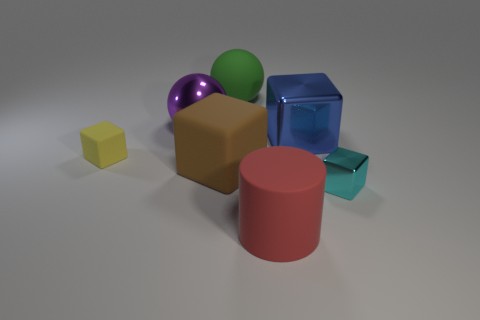There is a big blue thing that is the same shape as the brown matte object; what material is it?
Provide a succinct answer. Metal. There is a shiny object that is left of the large block on the left side of the metal cube behind the small metal cube; what is its size?
Provide a succinct answer. Large. Do the cylinder and the cyan cube have the same size?
Offer a very short reply. No. There is a sphere that is left of the big ball to the right of the metallic sphere; what is it made of?
Provide a short and direct response. Metal. Do the tiny thing that is to the left of the blue thing and the big blue metal object behind the brown rubber object have the same shape?
Keep it short and to the point. Yes. Are there the same number of big green matte balls that are in front of the big metal cube and small cyan blocks?
Offer a very short reply. No. Are there any matte spheres that are on the left side of the matte object that is behind the large blue shiny object?
Make the answer very short. No. Is there anything else that has the same color as the small metal cube?
Offer a very short reply. No. Do the cube behind the yellow rubber object and the large brown thing have the same material?
Ensure brevity in your answer.  No. Are there an equal number of big rubber spheres that are in front of the cyan shiny thing and tiny matte blocks right of the green ball?
Your answer should be very brief. Yes. 